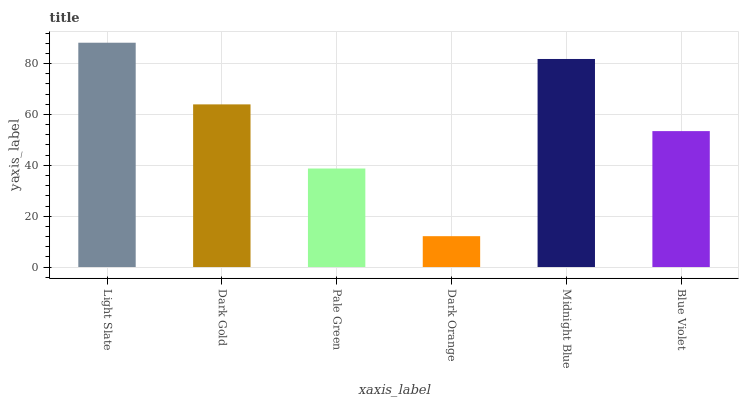Is Dark Gold the minimum?
Answer yes or no. No. Is Dark Gold the maximum?
Answer yes or no. No. Is Light Slate greater than Dark Gold?
Answer yes or no. Yes. Is Dark Gold less than Light Slate?
Answer yes or no. Yes. Is Dark Gold greater than Light Slate?
Answer yes or no. No. Is Light Slate less than Dark Gold?
Answer yes or no. No. Is Dark Gold the high median?
Answer yes or no. Yes. Is Blue Violet the low median?
Answer yes or no. Yes. Is Dark Orange the high median?
Answer yes or no. No. Is Midnight Blue the low median?
Answer yes or no. No. 